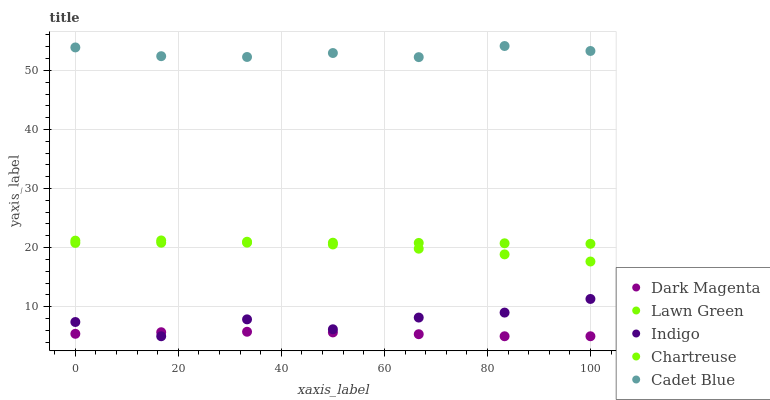Does Dark Magenta have the minimum area under the curve?
Answer yes or no. Yes. Does Cadet Blue have the maximum area under the curve?
Answer yes or no. Yes. Does Chartreuse have the minimum area under the curve?
Answer yes or no. No. Does Chartreuse have the maximum area under the curve?
Answer yes or no. No. Is Lawn Green the smoothest?
Answer yes or no. Yes. Is Indigo the roughest?
Answer yes or no. Yes. Is Chartreuse the smoothest?
Answer yes or no. No. Is Chartreuse the roughest?
Answer yes or no. No. Does Indigo have the lowest value?
Answer yes or no. Yes. Does Chartreuse have the lowest value?
Answer yes or no. No. Does Cadet Blue have the highest value?
Answer yes or no. Yes. Does Chartreuse have the highest value?
Answer yes or no. No. Is Dark Magenta less than Lawn Green?
Answer yes or no. Yes. Is Chartreuse greater than Indigo?
Answer yes or no. Yes. Does Indigo intersect Dark Magenta?
Answer yes or no. Yes. Is Indigo less than Dark Magenta?
Answer yes or no. No. Is Indigo greater than Dark Magenta?
Answer yes or no. No. Does Dark Magenta intersect Lawn Green?
Answer yes or no. No. 